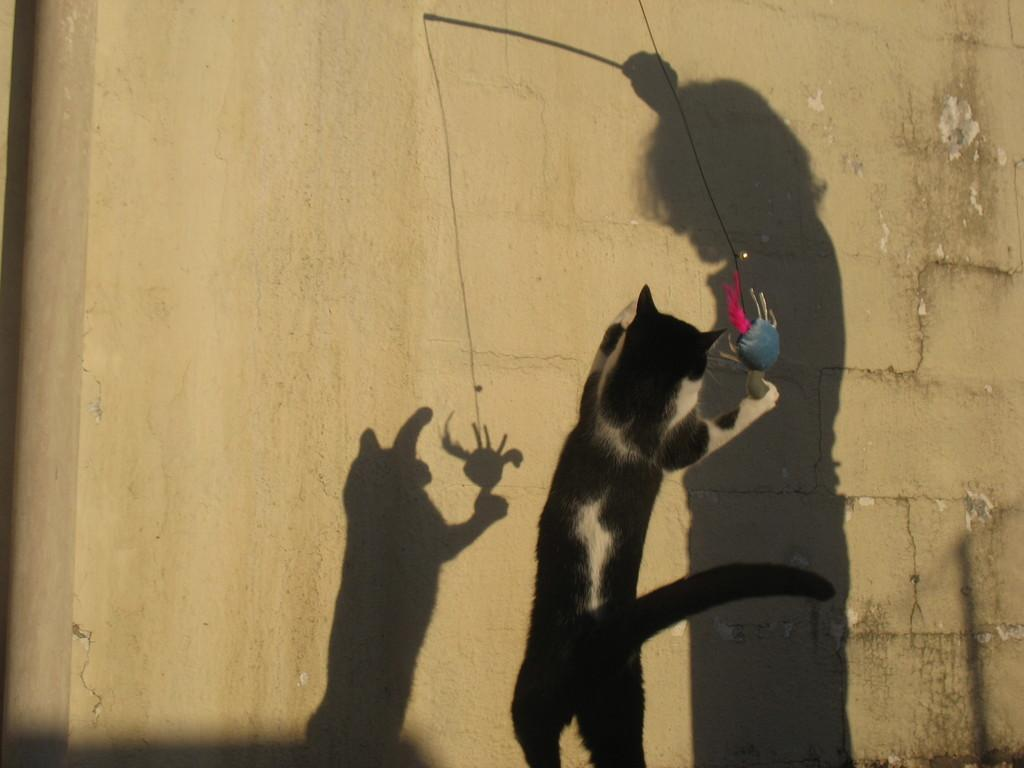What type of animal is present in the image? There is a cat in the image. Can you describe any additional features in the image? There are shadows of a person and a cat on the wall in the image. What type of cloth is draped over the snakes in the image? There are no snakes or cloth present in the image; it features a cat and shadows of a person and a cat on the wall. 